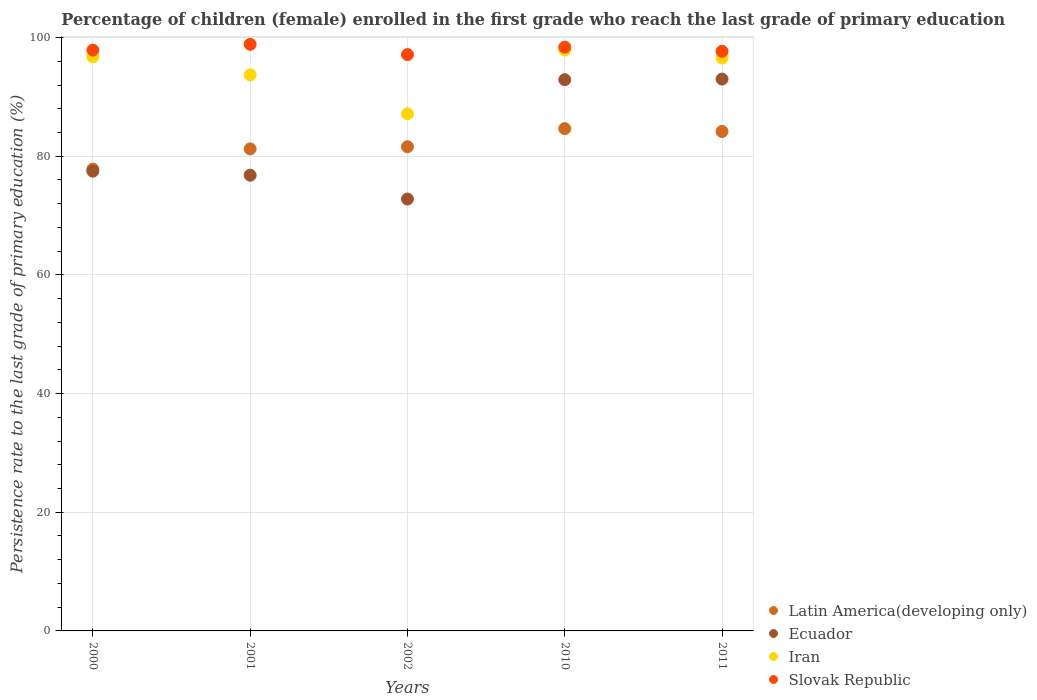How many different coloured dotlines are there?
Provide a short and direct response. 4. What is the persistence rate of children in Slovak Republic in 2001?
Ensure brevity in your answer.  98.86. Across all years, what is the maximum persistence rate of children in Slovak Republic?
Your response must be concise. 98.86. Across all years, what is the minimum persistence rate of children in Slovak Republic?
Keep it short and to the point. 97.13. In which year was the persistence rate of children in Slovak Republic maximum?
Provide a succinct answer. 2001. In which year was the persistence rate of children in Latin America(developing only) minimum?
Ensure brevity in your answer.  2000. What is the total persistence rate of children in Latin America(developing only) in the graph?
Your answer should be very brief. 409.5. What is the difference between the persistence rate of children in Slovak Republic in 2001 and that in 2002?
Offer a very short reply. 1.74. What is the difference between the persistence rate of children in Iran in 2002 and the persistence rate of children in Ecuador in 2000?
Your response must be concise. 9.67. What is the average persistence rate of children in Iran per year?
Provide a short and direct response. 94.41. In the year 2011, what is the difference between the persistence rate of children in Slovak Republic and persistence rate of children in Ecuador?
Ensure brevity in your answer.  4.68. In how many years, is the persistence rate of children in Ecuador greater than 52 %?
Your response must be concise. 5. What is the ratio of the persistence rate of children in Latin America(developing only) in 2000 to that in 2002?
Give a very brief answer. 0.95. Is the difference between the persistence rate of children in Slovak Republic in 2000 and 2011 greater than the difference between the persistence rate of children in Ecuador in 2000 and 2011?
Your answer should be compact. Yes. What is the difference between the highest and the second highest persistence rate of children in Slovak Republic?
Offer a terse response. 0.48. What is the difference between the highest and the lowest persistence rate of children in Iran?
Your answer should be very brief. 10.74. Is the sum of the persistence rate of children in Slovak Republic in 2002 and 2011 greater than the maximum persistence rate of children in Iran across all years?
Ensure brevity in your answer.  Yes. Is it the case that in every year, the sum of the persistence rate of children in Ecuador and persistence rate of children in Slovak Republic  is greater than the sum of persistence rate of children in Latin America(developing only) and persistence rate of children in Iran?
Your response must be concise. No. Does the persistence rate of children in Ecuador monotonically increase over the years?
Give a very brief answer. No. Is the persistence rate of children in Slovak Republic strictly greater than the persistence rate of children in Latin America(developing only) over the years?
Give a very brief answer. Yes. How many dotlines are there?
Offer a very short reply. 4. Are the values on the major ticks of Y-axis written in scientific E-notation?
Offer a terse response. No. Does the graph contain grids?
Your answer should be compact. Yes. How many legend labels are there?
Your response must be concise. 4. How are the legend labels stacked?
Keep it short and to the point. Vertical. What is the title of the graph?
Keep it short and to the point. Percentage of children (female) enrolled in the first grade who reach the last grade of primary education. Does "United States" appear as one of the legend labels in the graph?
Your answer should be compact. No. What is the label or title of the X-axis?
Ensure brevity in your answer.  Years. What is the label or title of the Y-axis?
Your answer should be compact. Persistence rate to the last grade of primary education (%). What is the Persistence rate to the last grade of primary education (%) in Latin America(developing only) in 2000?
Give a very brief answer. 77.83. What is the Persistence rate to the last grade of primary education (%) of Ecuador in 2000?
Make the answer very short. 77.49. What is the Persistence rate to the last grade of primary education (%) in Iran in 2000?
Ensure brevity in your answer.  96.74. What is the Persistence rate to the last grade of primary education (%) in Slovak Republic in 2000?
Give a very brief answer. 97.89. What is the Persistence rate to the last grade of primary education (%) of Latin America(developing only) in 2001?
Offer a terse response. 81.24. What is the Persistence rate to the last grade of primary education (%) in Ecuador in 2001?
Your answer should be very brief. 76.8. What is the Persistence rate to the last grade of primary education (%) in Iran in 2001?
Ensure brevity in your answer.  93.71. What is the Persistence rate to the last grade of primary education (%) of Slovak Republic in 2001?
Offer a very short reply. 98.86. What is the Persistence rate to the last grade of primary education (%) of Latin America(developing only) in 2002?
Make the answer very short. 81.6. What is the Persistence rate to the last grade of primary education (%) of Ecuador in 2002?
Offer a very short reply. 72.79. What is the Persistence rate to the last grade of primary education (%) in Iran in 2002?
Offer a very short reply. 87.16. What is the Persistence rate to the last grade of primary education (%) in Slovak Republic in 2002?
Offer a terse response. 97.13. What is the Persistence rate to the last grade of primary education (%) of Latin America(developing only) in 2010?
Provide a short and direct response. 84.65. What is the Persistence rate to the last grade of primary education (%) of Ecuador in 2010?
Ensure brevity in your answer.  92.9. What is the Persistence rate to the last grade of primary education (%) in Iran in 2010?
Your answer should be very brief. 97.9. What is the Persistence rate to the last grade of primary education (%) of Slovak Republic in 2010?
Your response must be concise. 98.38. What is the Persistence rate to the last grade of primary education (%) in Latin America(developing only) in 2011?
Provide a succinct answer. 84.17. What is the Persistence rate to the last grade of primary education (%) in Ecuador in 2011?
Provide a short and direct response. 93.01. What is the Persistence rate to the last grade of primary education (%) of Iran in 2011?
Ensure brevity in your answer.  96.55. What is the Persistence rate to the last grade of primary education (%) of Slovak Republic in 2011?
Keep it short and to the point. 97.68. Across all years, what is the maximum Persistence rate to the last grade of primary education (%) of Latin America(developing only)?
Offer a very short reply. 84.65. Across all years, what is the maximum Persistence rate to the last grade of primary education (%) of Ecuador?
Keep it short and to the point. 93.01. Across all years, what is the maximum Persistence rate to the last grade of primary education (%) in Iran?
Provide a succinct answer. 97.9. Across all years, what is the maximum Persistence rate to the last grade of primary education (%) in Slovak Republic?
Your response must be concise. 98.86. Across all years, what is the minimum Persistence rate to the last grade of primary education (%) of Latin America(developing only)?
Your answer should be compact. 77.83. Across all years, what is the minimum Persistence rate to the last grade of primary education (%) in Ecuador?
Ensure brevity in your answer.  72.79. Across all years, what is the minimum Persistence rate to the last grade of primary education (%) in Iran?
Make the answer very short. 87.16. Across all years, what is the minimum Persistence rate to the last grade of primary education (%) in Slovak Republic?
Ensure brevity in your answer.  97.13. What is the total Persistence rate to the last grade of primary education (%) in Latin America(developing only) in the graph?
Offer a very short reply. 409.5. What is the total Persistence rate to the last grade of primary education (%) in Ecuador in the graph?
Give a very brief answer. 412.99. What is the total Persistence rate to the last grade of primary education (%) in Iran in the graph?
Ensure brevity in your answer.  472.07. What is the total Persistence rate to the last grade of primary education (%) of Slovak Republic in the graph?
Offer a terse response. 489.95. What is the difference between the Persistence rate to the last grade of primary education (%) of Latin America(developing only) in 2000 and that in 2001?
Offer a terse response. -3.41. What is the difference between the Persistence rate to the last grade of primary education (%) of Ecuador in 2000 and that in 2001?
Your answer should be compact. 0.68. What is the difference between the Persistence rate to the last grade of primary education (%) in Iran in 2000 and that in 2001?
Offer a terse response. 3.03. What is the difference between the Persistence rate to the last grade of primary education (%) of Slovak Republic in 2000 and that in 2001?
Offer a very short reply. -0.98. What is the difference between the Persistence rate to the last grade of primary education (%) in Latin America(developing only) in 2000 and that in 2002?
Make the answer very short. -3.77. What is the difference between the Persistence rate to the last grade of primary education (%) of Ecuador in 2000 and that in 2002?
Your answer should be compact. 4.7. What is the difference between the Persistence rate to the last grade of primary education (%) in Iran in 2000 and that in 2002?
Your response must be concise. 9.58. What is the difference between the Persistence rate to the last grade of primary education (%) in Slovak Republic in 2000 and that in 2002?
Ensure brevity in your answer.  0.76. What is the difference between the Persistence rate to the last grade of primary education (%) of Latin America(developing only) in 2000 and that in 2010?
Offer a very short reply. -6.82. What is the difference between the Persistence rate to the last grade of primary education (%) of Ecuador in 2000 and that in 2010?
Your answer should be very brief. -15.42. What is the difference between the Persistence rate to the last grade of primary education (%) in Iran in 2000 and that in 2010?
Provide a succinct answer. -1.16. What is the difference between the Persistence rate to the last grade of primary education (%) in Slovak Republic in 2000 and that in 2010?
Offer a terse response. -0.5. What is the difference between the Persistence rate to the last grade of primary education (%) in Latin America(developing only) in 2000 and that in 2011?
Keep it short and to the point. -6.34. What is the difference between the Persistence rate to the last grade of primary education (%) in Ecuador in 2000 and that in 2011?
Keep it short and to the point. -15.52. What is the difference between the Persistence rate to the last grade of primary education (%) in Iran in 2000 and that in 2011?
Keep it short and to the point. 0.19. What is the difference between the Persistence rate to the last grade of primary education (%) in Slovak Republic in 2000 and that in 2011?
Offer a very short reply. 0.2. What is the difference between the Persistence rate to the last grade of primary education (%) of Latin America(developing only) in 2001 and that in 2002?
Ensure brevity in your answer.  -0.36. What is the difference between the Persistence rate to the last grade of primary education (%) in Ecuador in 2001 and that in 2002?
Offer a very short reply. 4.02. What is the difference between the Persistence rate to the last grade of primary education (%) of Iran in 2001 and that in 2002?
Provide a short and direct response. 6.55. What is the difference between the Persistence rate to the last grade of primary education (%) in Slovak Republic in 2001 and that in 2002?
Give a very brief answer. 1.74. What is the difference between the Persistence rate to the last grade of primary education (%) in Latin America(developing only) in 2001 and that in 2010?
Provide a succinct answer. -3.42. What is the difference between the Persistence rate to the last grade of primary education (%) in Ecuador in 2001 and that in 2010?
Your answer should be compact. -16.1. What is the difference between the Persistence rate to the last grade of primary education (%) of Iran in 2001 and that in 2010?
Provide a short and direct response. -4.19. What is the difference between the Persistence rate to the last grade of primary education (%) of Slovak Republic in 2001 and that in 2010?
Offer a very short reply. 0.48. What is the difference between the Persistence rate to the last grade of primary education (%) in Latin America(developing only) in 2001 and that in 2011?
Keep it short and to the point. -2.94. What is the difference between the Persistence rate to the last grade of primary education (%) of Ecuador in 2001 and that in 2011?
Give a very brief answer. -16.2. What is the difference between the Persistence rate to the last grade of primary education (%) of Iran in 2001 and that in 2011?
Provide a succinct answer. -2.84. What is the difference between the Persistence rate to the last grade of primary education (%) of Slovak Republic in 2001 and that in 2011?
Offer a terse response. 1.18. What is the difference between the Persistence rate to the last grade of primary education (%) in Latin America(developing only) in 2002 and that in 2010?
Keep it short and to the point. -3.05. What is the difference between the Persistence rate to the last grade of primary education (%) of Ecuador in 2002 and that in 2010?
Your response must be concise. -20.12. What is the difference between the Persistence rate to the last grade of primary education (%) in Iran in 2002 and that in 2010?
Make the answer very short. -10.74. What is the difference between the Persistence rate to the last grade of primary education (%) of Slovak Republic in 2002 and that in 2010?
Ensure brevity in your answer.  -1.25. What is the difference between the Persistence rate to the last grade of primary education (%) in Latin America(developing only) in 2002 and that in 2011?
Give a very brief answer. -2.57. What is the difference between the Persistence rate to the last grade of primary education (%) in Ecuador in 2002 and that in 2011?
Your answer should be very brief. -20.22. What is the difference between the Persistence rate to the last grade of primary education (%) in Iran in 2002 and that in 2011?
Keep it short and to the point. -9.39. What is the difference between the Persistence rate to the last grade of primary education (%) of Slovak Republic in 2002 and that in 2011?
Your response must be concise. -0.56. What is the difference between the Persistence rate to the last grade of primary education (%) of Latin America(developing only) in 2010 and that in 2011?
Offer a very short reply. 0.48. What is the difference between the Persistence rate to the last grade of primary education (%) in Ecuador in 2010 and that in 2011?
Give a very brief answer. -0.1. What is the difference between the Persistence rate to the last grade of primary education (%) in Iran in 2010 and that in 2011?
Your answer should be compact. 1.35. What is the difference between the Persistence rate to the last grade of primary education (%) of Slovak Republic in 2010 and that in 2011?
Your answer should be very brief. 0.7. What is the difference between the Persistence rate to the last grade of primary education (%) in Latin America(developing only) in 2000 and the Persistence rate to the last grade of primary education (%) in Ecuador in 2001?
Make the answer very short. 1.03. What is the difference between the Persistence rate to the last grade of primary education (%) in Latin America(developing only) in 2000 and the Persistence rate to the last grade of primary education (%) in Iran in 2001?
Provide a short and direct response. -15.88. What is the difference between the Persistence rate to the last grade of primary education (%) of Latin America(developing only) in 2000 and the Persistence rate to the last grade of primary education (%) of Slovak Republic in 2001?
Your answer should be very brief. -21.03. What is the difference between the Persistence rate to the last grade of primary education (%) in Ecuador in 2000 and the Persistence rate to the last grade of primary education (%) in Iran in 2001?
Provide a short and direct response. -16.23. What is the difference between the Persistence rate to the last grade of primary education (%) in Ecuador in 2000 and the Persistence rate to the last grade of primary education (%) in Slovak Republic in 2001?
Offer a terse response. -21.38. What is the difference between the Persistence rate to the last grade of primary education (%) of Iran in 2000 and the Persistence rate to the last grade of primary education (%) of Slovak Republic in 2001?
Offer a terse response. -2.12. What is the difference between the Persistence rate to the last grade of primary education (%) in Latin America(developing only) in 2000 and the Persistence rate to the last grade of primary education (%) in Ecuador in 2002?
Offer a terse response. 5.04. What is the difference between the Persistence rate to the last grade of primary education (%) of Latin America(developing only) in 2000 and the Persistence rate to the last grade of primary education (%) of Iran in 2002?
Offer a terse response. -9.33. What is the difference between the Persistence rate to the last grade of primary education (%) in Latin America(developing only) in 2000 and the Persistence rate to the last grade of primary education (%) in Slovak Republic in 2002?
Give a very brief answer. -19.3. What is the difference between the Persistence rate to the last grade of primary education (%) in Ecuador in 2000 and the Persistence rate to the last grade of primary education (%) in Iran in 2002?
Provide a succinct answer. -9.67. What is the difference between the Persistence rate to the last grade of primary education (%) in Ecuador in 2000 and the Persistence rate to the last grade of primary education (%) in Slovak Republic in 2002?
Ensure brevity in your answer.  -19.64. What is the difference between the Persistence rate to the last grade of primary education (%) in Iran in 2000 and the Persistence rate to the last grade of primary education (%) in Slovak Republic in 2002?
Your response must be concise. -0.38. What is the difference between the Persistence rate to the last grade of primary education (%) of Latin America(developing only) in 2000 and the Persistence rate to the last grade of primary education (%) of Ecuador in 2010?
Offer a very short reply. -15.07. What is the difference between the Persistence rate to the last grade of primary education (%) in Latin America(developing only) in 2000 and the Persistence rate to the last grade of primary education (%) in Iran in 2010?
Your answer should be compact. -20.07. What is the difference between the Persistence rate to the last grade of primary education (%) in Latin America(developing only) in 2000 and the Persistence rate to the last grade of primary education (%) in Slovak Republic in 2010?
Give a very brief answer. -20.55. What is the difference between the Persistence rate to the last grade of primary education (%) of Ecuador in 2000 and the Persistence rate to the last grade of primary education (%) of Iran in 2010?
Provide a succinct answer. -20.41. What is the difference between the Persistence rate to the last grade of primary education (%) of Ecuador in 2000 and the Persistence rate to the last grade of primary education (%) of Slovak Republic in 2010?
Give a very brief answer. -20.89. What is the difference between the Persistence rate to the last grade of primary education (%) of Iran in 2000 and the Persistence rate to the last grade of primary education (%) of Slovak Republic in 2010?
Make the answer very short. -1.64. What is the difference between the Persistence rate to the last grade of primary education (%) in Latin America(developing only) in 2000 and the Persistence rate to the last grade of primary education (%) in Ecuador in 2011?
Ensure brevity in your answer.  -15.18. What is the difference between the Persistence rate to the last grade of primary education (%) of Latin America(developing only) in 2000 and the Persistence rate to the last grade of primary education (%) of Iran in 2011?
Provide a short and direct response. -18.72. What is the difference between the Persistence rate to the last grade of primary education (%) in Latin America(developing only) in 2000 and the Persistence rate to the last grade of primary education (%) in Slovak Republic in 2011?
Ensure brevity in your answer.  -19.85. What is the difference between the Persistence rate to the last grade of primary education (%) of Ecuador in 2000 and the Persistence rate to the last grade of primary education (%) of Iran in 2011?
Offer a terse response. -19.07. What is the difference between the Persistence rate to the last grade of primary education (%) in Ecuador in 2000 and the Persistence rate to the last grade of primary education (%) in Slovak Republic in 2011?
Ensure brevity in your answer.  -20.2. What is the difference between the Persistence rate to the last grade of primary education (%) of Iran in 2000 and the Persistence rate to the last grade of primary education (%) of Slovak Republic in 2011?
Your answer should be compact. -0.94. What is the difference between the Persistence rate to the last grade of primary education (%) in Latin America(developing only) in 2001 and the Persistence rate to the last grade of primary education (%) in Ecuador in 2002?
Make the answer very short. 8.45. What is the difference between the Persistence rate to the last grade of primary education (%) of Latin America(developing only) in 2001 and the Persistence rate to the last grade of primary education (%) of Iran in 2002?
Provide a succinct answer. -5.92. What is the difference between the Persistence rate to the last grade of primary education (%) of Latin America(developing only) in 2001 and the Persistence rate to the last grade of primary education (%) of Slovak Republic in 2002?
Give a very brief answer. -15.89. What is the difference between the Persistence rate to the last grade of primary education (%) of Ecuador in 2001 and the Persistence rate to the last grade of primary education (%) of Iran in 2002?
Your answer should be compact. -10.36. What is the difference between the Persistence rate to the last grade of primary education (%) in Ecuador in 2001 and the Persistence rate to the last grade of primary education (%) in Slovak Republic in 2002?
Ensure brevity in your answer.  -20.33. What is the difference between the Persistence rate to the last grade of primary education (%) in Iran in 2001 and the Persistence rate to the last grade of primary education (%) in Slovak Republic in 2002?
Make the answer very short. -3.42. What is the difference between the Persistence rate to the last grade of primary education (%) of Latin America(developing only) in 2001 and the Persistence rate to the last grade of primary education (%) of Ecuador in 2010?
Your answer should be very brief. -11.67. What is the difference between the Persistence rate to the last grade of primary education (%) in Latin America(developing only) in 2001 and the Persistence rate to the last grade of primary education (%) in Iran in 2010?
Offer a terse response. -16.66. What is the difference between the Persistence rate to the last grade of primary education (%) in Latin America(developing only) in 2001 and the Persistence rate to the last grade of primary education (%) in Slovak Republic in 2010?
Offer a terse response. -17.14. What is the difference between the Persistence rate to the last grade of primary education (%) of Ecuador in 2001 and the Persistence rate to the last grade of primary education (%) of Iran in 2010?
Your answer should be very brief. -21.1. What is the difference between the Persistence rate to the last grade of primary education (%) of Ecuador in 2001 and the Persistence rate to the last grade of primary education (%) of Slovak Republic in 2010?
Offer a very short reply. -21.58. What is the difference between the Persistence rate to the last grade of primary education (%) of Iran in 2001 and the Persistence rate to the last grade of primary education (%) of Slovak Republic in 2010?
Give a very brief answer. -4.67. What is the difference between the Persistence rate to the last grade of primary education (%) in Latin America(developing only) in 2001 and the Persistence rate to the last grade of primary education (%) in Ecuador in 2011?
Offer a very short reply. -11.77. What is the difference between the Persistence rate to the last grade of primary education (%) of Latin America(developing only) in 2001 and the Persistence rate to the last grade of primary education (%) of Iran in 2011?
Your answer should be very brief. -15.32. What is the difference between the Persistence rate to the last grade of primary education (%) in Latin America(developing only) in 2001 and the Persistence rate to the last grade of primary education (%) in Slovak Republic in 2011?
Give a very brief answer. -16.45. What is the difference between the Persistence rate to the last grade of primary education (%) of Ecuador in 2001 and the Persistence rate to the last grade of primary education (%) of Iran in 2011?
Provide a short and direct response. -19.75. What is the difference between the Persistence rate to the last grade of primary education (%) in Ecuador in 2001 and the Persistence rate to the last grade of primary education (%) in Slovak Republic in 2011?
Provide a succinct answer. -20.88. What is the difference between the Persistence rate to the last grade of primary education (%) of Iran in 2001 and the Persistence rate to the last grade of primary education (%) of Slovak Republic in 2011?
Provide a succinct answer. -3.97. What is the difference between the Persistence rate to the last grade of primary education (%) of Latin America(developing only) in 2002 and the Persistence rate to the last grade of primary education (%) of Ecuador in 2010?
Give a very brief answer. -11.3. What is the difference between the Persistence rate to the last grade of primary education (%) of Latin America(developing only) in 2002 and the Persistence rate to the last grade of primary education (%) of Iran in 2010?
Offer a terse response. -16.3. What is the difference between the Persistence rate to the last grade of primary education (%) in Latin America(developing only) in 2002 and the Persistence rate to the last grade of primary education (%) in Slovak Republic in 2010?
Your answer should be compact. -16.78. What is the difference between the Persistence rate to the last grade of primary education (%) of Ecuador in 2002 and the Persistence rate to the last grade of primary education (%) of Iran in 2010?
Make the answer very short. -25.11. What is the difference between the Persistence rate to the last grade of primary education (%) of Ecuador in 2002 and the Persistence rate to the last grade of primary education (%) of Slovak Republic in 2010?
Your response must be concise. -25.6. What is the difference between the Persistence rate to the last grade of primary education (%) in Iran in 2002 and the Persistence rate to the last grade of primary education (%) in Slovak Republic in 2010?
Offer a terse response. -11.22. What is the difference between the Persistence rate to the last grade of primary education (%) of Latin America(developing only) in 2002 and the Persistence rate to the last grade of primary education (%) of Ecuador in 2011?
Make the answer very short. -11.41. What is the difference between the Persistence rate to the last grade of primary education (%) of Latin America(developing only) in 2002 and the Persistence rate to the last grade of primary education (%) of Iran in 2011?
Make the answer very short. -14.95. What is the difference between the Persistence rate to the last grade of primary education (%) of Latin America(developing only) in 2002 and the Persistence rate to the last grade of primary education (%) of Slovak Republic in 2011?
Your answer should be compact. -16.08. What is the difference between the Persistence rate to the last grade of primary education (%) of Ecuador in 2002 and the Persistence rate to the last grade of primary education (%) of Iran in 2011?
Ensure brevity in your answer.  -23.77. What is the difference between the Persistence rate to the last grade of primary education (%) of Ecuador in 2002 and the Persistence rate to the last grade of primary education (%) of Slovak Republic in 2011?
Your answer should be very brief. -24.9. What is the difference between the Persistence rate to the last grade of primary education (%) in Iran in 2002 and the Persistence rate to the last grade of primary education (%) in Slovak Republic in 2011?
Make the answer very short. -10.52. What is the difference between the Persistence rate to the last grade of primary education (%) of Latin America(developing only) in 2010 and the Persistence rate to the last grade of primary education (%) of Ecuador in 2011?
Offer a very short reply. -8.35. What is the difference between the Persistence rate to the last grade of primary education (%) in Latin America(developing only) in 2010 and the Persistence rate to the last grade of primary education (%) in Iran in 2011?
Ensure brevity in your answer.  -11.9. What is the difference between the Persistence rate to the last grade of primary education (%) of Latin America(developing only) in 2010 and the Persistence rate to the last grade of primary education (%) of Slovak Republic in 2011?
Ensure brevity in your answer.  -13.03. What is the difference between the Persistence rate to the last grade of primary education (%) of Ecuador in 2010 and the Persistence rate to the last grade of primary education (%) of Iran in 2011?
Your response must be concise. -3.65. What is the difference between the Persistence rate to the last grade of primary education (%) of Ecuador in 2010 and the Persistence rate to the last grade of primary education (%) of Slovak Republic in 2011?
Your answer should be very brief. -4.78. What is the difference between the Persistence rate to the last grade of primary education (%) of Iran in 2010 and the Persistence rate to the last grade of primary education (%) of Slovak Republic in 2011?
Your response must be concise. 0.22. What is the average Persistence rate to the last grade of primary education (%) in Latin America(developing only) per year?
Provide a succinct answer. 81.9. What is the average Persistence rate to the last grade of primary education (%) in Ecuador per year?
Your answer should be compact. 82.6. What is the average Persistence rate to the last grade of primary education (%) in Iran per year?
Offer a terse response. 94.41. What is the average Persistence rate to the last grade of primary education (%) of Slovak Republic per year?
Make the answer very short. 97.99. In the year 2000, what is the difference between the Persistence rate to the last grade of primary education (%) of Latin America(developing only) and Persistence rate to the last grade of primary education (%) of Ecuador?
Give a very brief answer. 0.34. In the year 2000, what is the difference between the Persistence rate to the last grade of primary education (%) of Latin America(developing only) and Persistence rate to the last grade of primary education (%) of Iran?
Provide a short and direct response. -18.91. In the year 2000, what is the difference between the Persistence rate to the last grade of primary education (%) of Latin America(developing only) and Persistence rate to the last grade of primary education (%) of Slovak Republic?
Your answer should be very brief. -20.06. In the year 2000, what is the difference between the Persistence rate to the last grade of primary education (%) in Ecuador and Persistence rate to the last grade of primary education (%) in Iran?
Your answer should be compact. -19.26. In the year 2000, what is the difference between the Persistence rate to the last grade of primary education (%) in Ecuador and Persistence rate to the last grade of primary education (%) in Slovak Republic?
Keep it short and to the point. -20.4. In the year 2000, what is the difference between the Persistence rate to the last grade of primary education (%) in Iran and Persistence rate to the last grade of primary education (%) in Slovak Republic?
Your answer should be compact. -1.14. In the year 2001, what is the difference between the Persistence rate to the last grade of primary education (%) in Latin America(developing only) and Persistence rate to the last grade of primary education (%) in Ecuador?
Offer a very short reply. 4.43. In the year 2001, what is the difference between the Persistence rate to the last grade of primary education (%) of Latin America(developing only) and Persistence rate to the last grade of primary education (%) of Iran?
Give a very brief answer. -12.48. In the year 2001, what is the difference between the Persistence rate to the last grade of primary education (%) in Latin America(developing only) and Persistence rate to the last grade of primary education (%) in Slovak Republic?
Offer a terse response. -17.63. In the year 2001, what is the difference between the Persistence rate to the last grade of primary education (%) of Ecuador and Persistence rate to the last grade of primary education (%) of Iran?
Offer a very short reply. -16.91. In the year 2001, what is the difference between the Persistence rate to the last grade of primary education (%) in Ecuador and Persistence rate to the last grade of primary education (%) in Slovak Republic?
Offer a very short reply. -22.06. In the year 2001, what is the difference between the Persistence rate to the last grade of primary education (%) in Iran and Persistence rate to the last grade of primary education (%) in Slovak Republic?
Give a very brief answer. -5.15. In the year 2002, what is the difference between the Persistence rate to the last grade of primary education (%) of Latin America(developing only) and Persistence rate to the last grade of primary education (%) of Ecuador?
Keep it short and to the point. 8.81. In the year 2002, what is the difference between the Persistence rate to the last grade of primary education (%) in Latin America(developing only) and Persistence rate to the last grade of primary education (%) in Iran?
Ensure brevity in your answer.  -5.56. In the year 2002, what is the difference between the Persistence rate to the last grade of primary education (%) in Latin America(developing only) and Persistence rate to the last grade of primary education (%) in Slovak Republic?
Provide a short and direct response. -15.53. In the year 2002, what is the difference between the Persistence rate to the last grade of primary education (%) of Ecuador and Persistence rate to the last grade of primary education (%) of Iran?
Make the answer very short. -14.37. In the year 2002, what is the difference between the Persistence rate to the last grade of primary education (%) of Ecuador and Persistence rate to the last grade of primary education (%) of Slovak Republic?
Your answer should be compact. -24.34. In the year 2002, what is the difference between the Persistence rate to the last grade of primary education (%) of Iran and Persistence rate to the last grade of primary education (%) of Slovak Republic?
Your answer should be compact. -9.97. In the year 2010, what is the difference between the Persistence rate to the last grade of primary education (%) in Latin America(developing only) and Persistence rate to the last grade of primary education (%) in Ecuador?
Provide a short and direct response. -8.25. In the year 2010, what is the difference between the Persistence rate to the last grade of primary education (%) of Latin America(developing only) and Persistence rate to the last grade of primary education (%) of Iran?
Offer a terse response. -13.25. In the year 2010, what is the difference between the Persistence rate to the last grade of primary education (%) of Latin America(developing only) and Persistence rate to the last grade of primary education (%) of Slovak Republic?
Your answer should be compact. -13.73. In the year 2010, what is the difference between the Persistence rate to the last grade of primary education (%) of Ecuador and Persistence rate to the last grade of primary education (%) of Iran?
Offer a very short reply. -5. In the year 2010, what is the difference between the Persistence rate to the last grade of primary education (%) of Ecuador and Persistence rate to the last grade of primary education (%) of Slovak Republic?
Make the answer very short. -5.48. In the year 2010, what is the difference between the Persistence rate to the last grade of primary education (%) of Iran and Persistence rate to the last grade of primary education (%) of Slovak Republic?
Keep it short and to the point. -0.48. In the year 2011, what is the difference between the Persistence rate to the last grade of primary education (%) of Latin America(developing only) and Persistence rate to the last grade of primary education (%) of Ecuador?
Make the answer very short. -8.83. In the year 2011, what is the difference between the Persistence rate to the last grade of primary education (%) of Latin America(developing only) and Persistence rate to the last grade of primary education (%) of Iran?
Keep it short and to the point. -12.38. In the year 2011, what is the difference between the Persistence rate to the last grade of primary education (%) of Latin America(developing only) and Persistence rate to the last grade of primary education (%) of Slovak Republic?
Offer a very short reply. -13.51. In the year 2011, what is the difference between the Persistence rate to the last grade of primary education (%) of Ecuador and Persistence rate to the last grade of primary education (%) of Iran?
Give a very brief answer. -3.55. In the year 2011, what is the difference between the Persistence rate to the last grade of primary education (%) of Ecuador and Persistence rate to the last grade of primary education (%) of Slovak Republic?
Give a very brief answer. -4.68. In the year 2011, what is the difference between the Persistence rate to the last grade of primary education (%) in Iran and Persistence rate to the last grade of primary education (%) in Slovak Republic?
Make the answer very short. -1.13. What is the ratio of the Persistence rate to the last grade of primary education (%) of Latin America(developing only) in 2000 to that in 2001?
Offer a terse response. 0.96. What is the ratio of the Persistence rate to the last grade of primary education (%) of Ecuador in 2000 to that in 2001?
Your answer should be very brief. 1.01. What is the ratio of the Persistence rate to the last grade of primary education (%) in Iran in 2000 to that in 2001?
Offer a very short reply. 1.03. What is the ratio of the Persistence rate to the last grade of primary education (%) of Slovak Republic in 2000 to that in 2001?
Your answer should be compact. 0.99. What is the ratio of the Persistence rate to the last grade of primary education (%) in Latin America(developing only) in 2000 to that in 2002?
Make the answer very short. 0.95. What is the ratio of the Persistence rate to the last grade of primary education (%) of Ecuador in 2000 to that in 2002?
Offer a terse response. 1.06. What is the ratio of the Persistence rate to the last grade of primary education (%) in Iran in 2000 to that in 2002?
Offer a terse response. 1.11. What is the ratio of the Persistence rate to the last grade of primary education (%) of Latin America(developing only) in 2000 to that in 2010?
Provide a short and direct response. 0.92. What is the ratio of the Persistence rate to the last grade of primary education (%) of Ecuador in 2000 to that in 2010?
Provide a succinct answer. 0.83. What is the ratio of the Persistence rate to the last grade of primary education (%) of Slovak Republic in 2000 to that in 2010?
Your answer should be compact. 0.99. What is the ratio of the Persistence rate to the last grade of primary education (%) of Latin America(developing only) in 2000 to that in 2011?
Provide a short and direct response. 0.92. What is the ratio of the Persistence rate to the last grade of primary education (%) of Ecuador in 2000 to that in 2011?
Keep it short and to the point. 0.83. What is the ratio of the Persistence rate to the last grade of primary education (%) in Latin America(developing only) in 2001 to that in 2002?
Your answer should be compact. 1. What is the ratio of the Persistence rate to the last grade of primary education (%) in Ecuador in 2001 to that in 2002?
Offer a very short reply. 1.06. What is the ratio of the Persistence rate to the last grade of primary education (%) in Iran in 2001 to that in 2002?
Offer a very short reply. 1.08. What is the ratio of the Persistence rate to the last grade of primary education (%) of Slovak Republic in 2001 to that in 2002?
Offer a very short reply. 1.02. What is the ratio of the Persistence rate to the last grade of primary education (%) in Latin America(developing only) in 2001 to that in 2010?
Your answer should be very brief. 0.96. What is the ratio of the Persistence rate to the last grade of primary education (%) in Ecuador in 2001 to that in 2010?
Offer a terse response. 0.83. What is the ratio of the Persistence rate to the last grade of primary education (%) in Iran in 2001 to that in 2010?
Offer a terse response. 0.96. What is the ratio of the Persistence rate to the last grade of primary education (%) in Slovak Republic in 2001 to that in 2010?
Give a very brief answer. 1. What is the ratio of the Persistence rate to the last grade of primary education (%) of Latin America(developing only) in 2001 to that in 2011?
Offer a terse response. 0.97. What is the ratio of the Persistence rate to the last grade of primary education (%) of Ecuador in 2001 to that in 2011?
Ensure brevity in your answer.  0.83. What is the ratio of the Persistence rate to the last grade of primary education (%) of Iran in 2001 to that in 2011?
Your answer should be compact. 0.97. What is the ratio of the Persistence rate to the last grade of primary education (%) of Slovak Republic in 2001 to that in 2011?
Keep it short and to the point. 1.01. What is the ratio of the Persistence rate to the last grade of primary education (%) of Latin America(developing only) in 2002 to that in 2010?
Keep it short and to the point. 0.96. What is the ratio of the Persistence rate to the last grade of primary education (%) in Ecuador in 2002 to that in 2010?
Give a very brief answer. 0.78. What is the ratio of the Persistence rate to the last grade of primary education (%) of Iran in 2002 to that in 2010?
Your response must be concise. 0.89. What is the ratio of the Persistence rate to the last grade of primary education (%) in Slovak Republic in 2002 to that in 2010?
Make the answer very short. 0.99. What is the ratio of the Persistence rate to the last grade of primary education (%) in Latin America(developing only) in 2002 to that in 2011?
Give a very brief answer. 0.97. What is the ratio of the Persistence rate to the last grade of primary education (%) in Ecuador in 2002 to that in 2011?
Offer a terse response. 0.78. What is the ratio of the Persistence rate to the last grade of primary education (%) of Iran in 2002 to that in 2011?
Your response must be concise. 0.9. What is the ratio of the Persistence rate to the last grade of primary education (%) in Ecuador in 2010 to that in 2011?
Provide a succinct answer. 1. What is the ratio of the Persistence rate to the last grade of primary education (%) of Slovak Republic in 2010 to that in 2011?
Your answer should be very brief. 1.01. What is the difference between the highest and the second highest Persistence rate to the last grade of primary education (%) of Latin America(developing only)?
Keep it short and to the point. 0.48. What is the difference between the highest and the second highest Persistence rate to the last grade of primary education (%) of Ecuador?
Give a very brief answer. 0.1. What is the difference between the highest and the second highest Persistence rate to the last grade of primary education (%) of Iran?
Offer a terse response. 1.16. What is the difference between the highest and the second highest Persistence rate to the last grade of primary education (%) of Slovak Republic?
Provide a short and direct response. 0.48. What is the difference between the highest and the lowest Persistence rate to the last grade of primary education (%) in Latin America(developing only)?
Make the answer very short. 6.82. What is the difference between the highest and the lowest Persistence rate to the last grade of primary education (%) in Ecuador?
Provide a short and direct response. 20.22. What is the difference between the highest and the lowest Persistence rate to the last grade of primary education (%) in Iran?
Give a very brief answer. 10.74. What is the difference between the highest and the lowest Persistence rate to the last grade of primary education (%) in Slovak Republic?
Offer a very short reply. 1.74. 